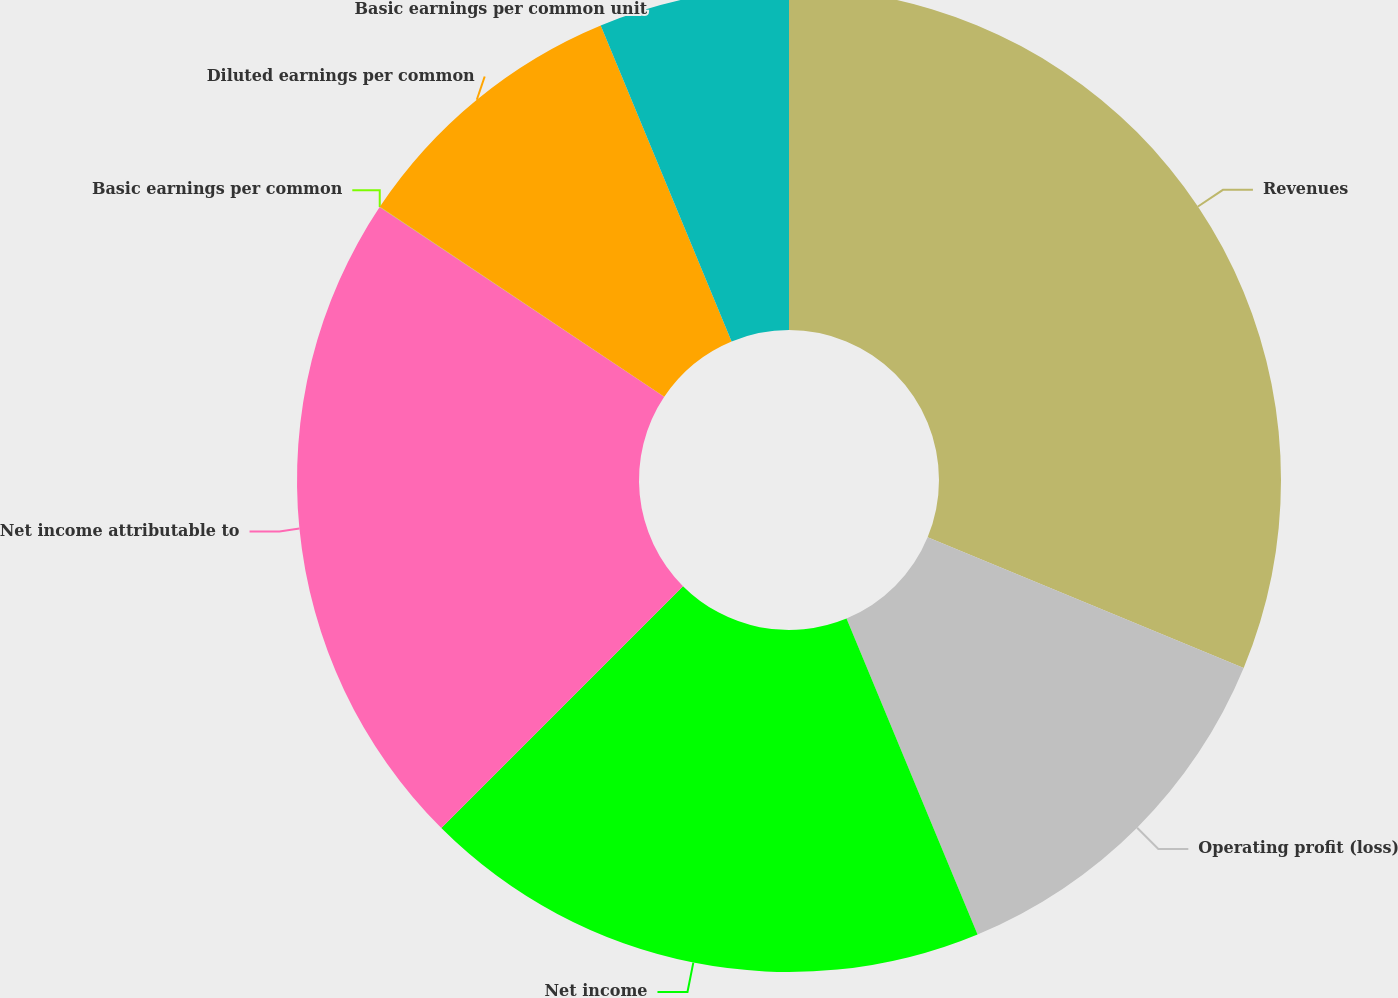<chart> <loc_0><loc_0><loc_500><loc_500><pie_chart><fcel>Revenues<fcel>Operating profit (loss)<fcel>Net income<fcel>Net income attributable to<fcel>Basic earnings per common<fcel>Diluted earnings per common<fcel>Basic earnings per common unit<nl><fcel>31.24%<fcel>12.5%<fcel>18.75%<fcel>21.87%<fcel>0.01%<fcel>9.38%<fcel>6.25%<nl></chart> 